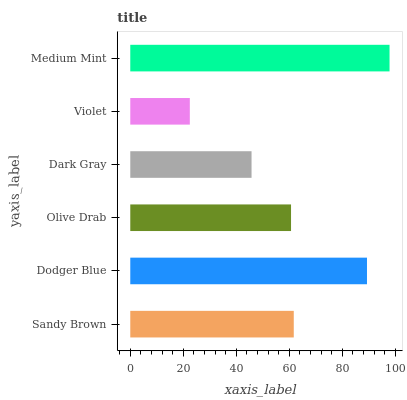Is Violet the minimum?
Answer yes or no. Yes. Is Medium Mint the maximum?
Answer yes or no. Yes. Is Dodger Blue the minimum?
Answer yes or no. No. Is Dodger Blue the maximum?
Answer yes or no. No. Is Dodger Blue greater than Sandy Brown?
Answer yes or no. Yes. Is Sandy Brown less than Dodger Blue?
Answer yes or no. Yes. Is Sandy Brown greater than Dodger Blue?
Answer yes or no. No. Is Dodger Blue less than Sandy Brown?
Answer yes or no. No. Is Sandy Brown the high median?
Answer yes or no. Yes. Is Olive Drab the low median?
Answer yes or no. Yes. Is Dark Gray the high median?
Answer yes or no. No. Is Dodger Blue the low median?
Answer yes or no. No. 